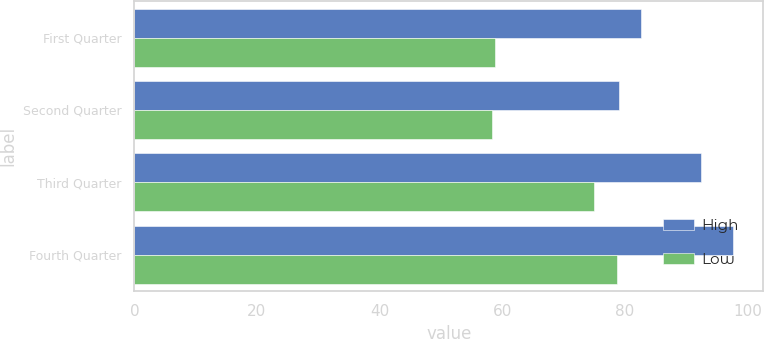Convert chart to OTSL. <chart><loc_0><loc_0><loc_500><loc_500><stacked_bar_chart><ecel><fcel>First Quarter<fcel>Second Quarter<fcel>Third Quarter<fcel>Fourth Quarter<nl><fcel>High<fcel>82.68<fcel>79.04<fcel>92.45<fcel>97.65<nl><fcel>Low<fcel>58.78<fcel>58.27<fcel>74.93<fcel>78.67<nl></chart> 